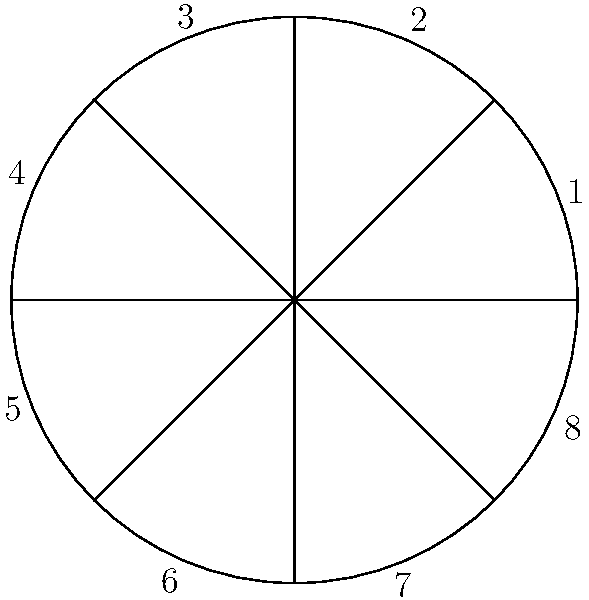In a healthcare decision-making committee, you want to ensure equal representation for 8 different community groups. You decide to visualize this using a circular diagram divided into equal sectors. If the central angle of each sector is $45°$, what is the sum of the central angles for sectors 3, 4, and 5? To solve this problem, let's follow these steps:

1. Understand the given information:
   - The circle is divided into 8 equal sectors.
   - Each sector represents a community group.
   - The central angle of each sector is $45°$.

2. Identify the sectors in question:
   - We need to find the sum of central angles for sectors 3, 4, and 5.

3. Calculate the sum:
   - Each sector has a central angle of $45°$.
   - We are considering 3 sectors (3, 4, and 5).
   - So, we multiply $45°$ by 3.

4. Perform the calculation:
   $45° \times 3 = 135°$

Therefore, the sum of the central angles for sectors 3, 4, and 5 is $135°$.
Answer: $135°$ 